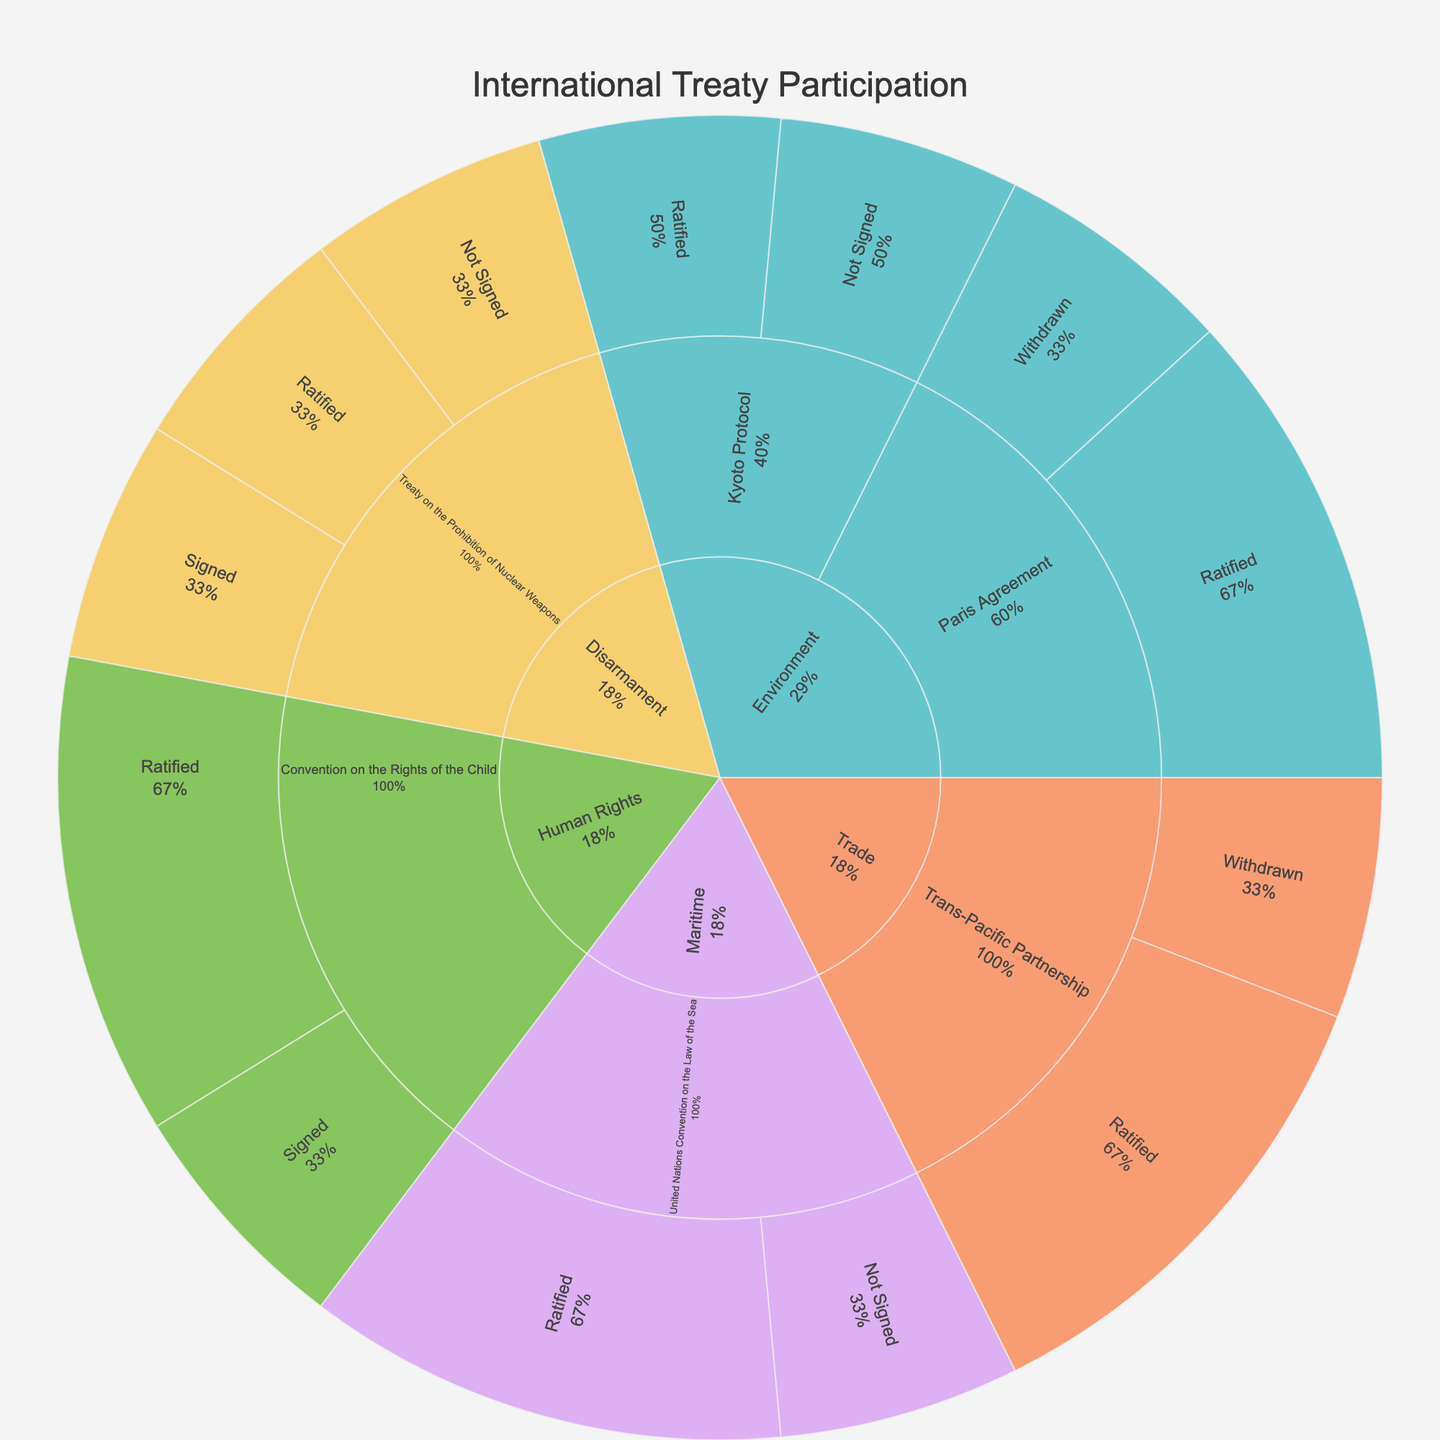What is the title of the plot? The title of the plot is usually found at the top center. It provides a concise description of what the plot represents.
Answer: International Treaty Participation Which subject has the highest overall participation count? To find the subject with the highest participation, look at the outermost ring segments and find the largest one based on its size representation in the sunburst plot.
Answer: Environment How many countries have ratified the "Trans-Pacific Partnership"? To answer this, locate the "Trans-Pacific Partnership" segment, then move to its sub-segments by status. Count the number of countries under the "Ratified" category.
Answer: 2 Which country has not signed the "Kyoto Protocol"? To identify this, find the "Kyoto Protocol" segment, then look at the sub-segments by status. Under "Not Signed," identify the country listed.
Answer: Canada What percentage of countries have "Withdrawn" from the Paris Agreement? Start by identifying all countries related to the Paris Agreement and then locate the "Withdrawn" status sub-segment. Calculate the percentage this sub-segment represents in relation to the entire Paris Agreement segment.
Answer: 1/3 or 33.3% How does the participation status between "Human Rights" and "Disarmament" compare? Look at the respective segments for both subjects and their breakdowns by status. Compare the number of countries in each status category to see how their participation differs.
Answer: Diverse participation statuses with both having at least one country not fully committed Which treaty under the "Maritime" subject matter has the most countries involved? Look under the "Maritime" subject and compare the sizes of the sub-segments representing each treaty. The largest sub-segment indicates the treaty with the most countries involved.
Answer: United Nations Convention on the Law of the Sea How many countries signed the "Treaty on the Prohibition of Nuclear Weapons"? Navigate to the "Treaty on the Prohibition of Nuclear Weapons" segment and find the "Signed" status segment. Count the number of countries.
Answer: 1 Which subject matter has the country with the most withdrawn treaties? Find the country with the "Withdrawn" status within different subject matters and identify the subject with the higher frequency of this status.
Answer: Trade (United States - Trans-Pacific Partnership) and Environment (United States - Paris Agreement) In the "Environment" subject, how many treaties have at least one country that did not sign? Look at the individual treaties under the "Environment" subject and count how many of them have a sub-segment labeled "Not Signed."
Answer: 1 